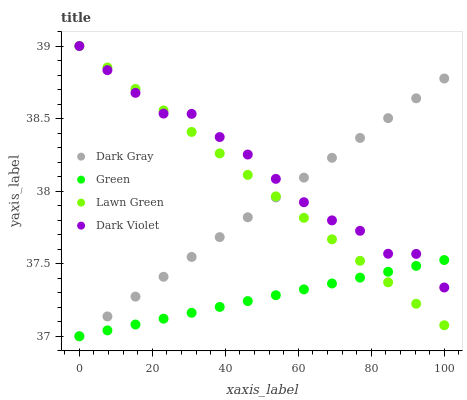Does Green have the minimum area under the curve?
Answer yes or no. Yes. Does Dark Violet have the maximum area under the curve?
Answer yes or no. Yes. Does Lawn Green have the minimum area under the curve?
Answer yes or no. No. Does Lawn Green have the maximum area under the curve?
Answer yes or no. No. Is Green the smoothest?
Answer yes or no. Yes. Is Dark Violet the roughest?
Answer yes or no. Yes. Is Lawn Green the smoothest?
Answer yes or no. No. Is Lawn Green the roughest?
Answer yes or no. No. Does Dark Gray have the lowest value?
Answer yes or no. Yes. Does Lawn Green have the lowest value?
Answer yes or no. No. Does Dark Violet have the highest value?
Answer yes or no. Yes. Does Green have the highest value?
Answer yes or no. No. Does Dark Violet intersect Dark Gray?
Answer yes or no. Yes. Is Dark Violet less than Dark Gray?
Answer yes or no. No. Is Dark Violet greater than Dark Gray?
Answer yes or no. No. 